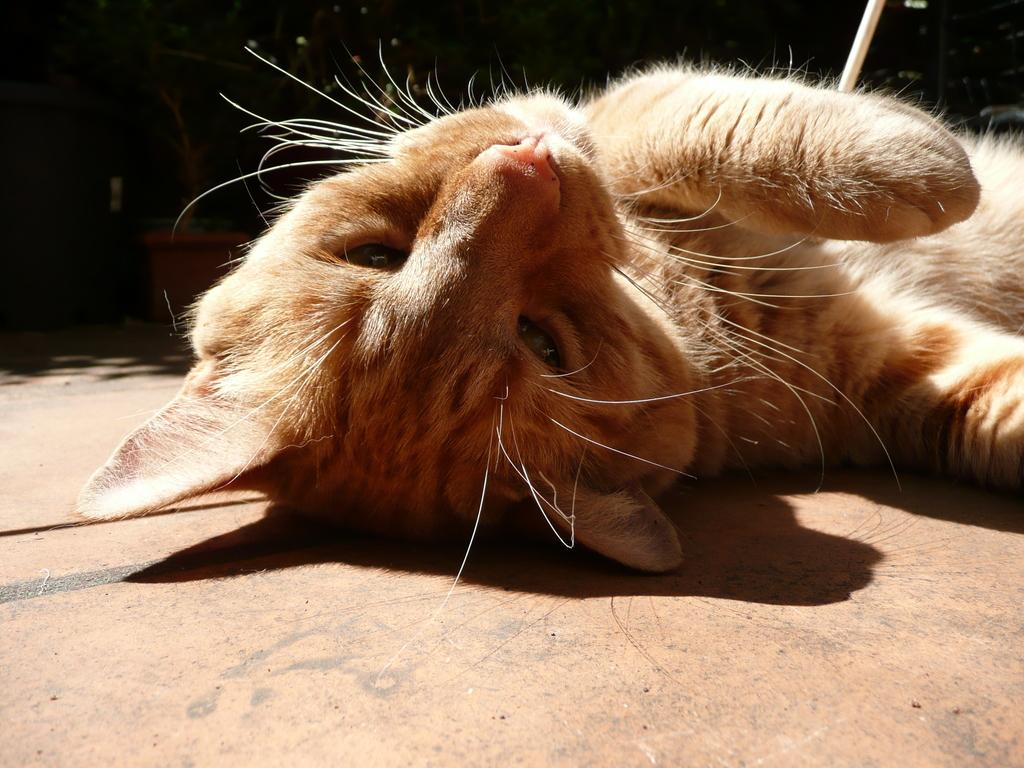What animal can be seen in the image? There is a cat in the image. What is the cat doing in the image? The cat is lying on the floor. What can be observed about the background of the image? The background of the image is dark. Is the cat wearing a veil in the image? No, the cat is not wearing a veil in the image. How many teeth can be seen in the image? There are no teeth visible in the image, as it features a cat lying on the floor. 